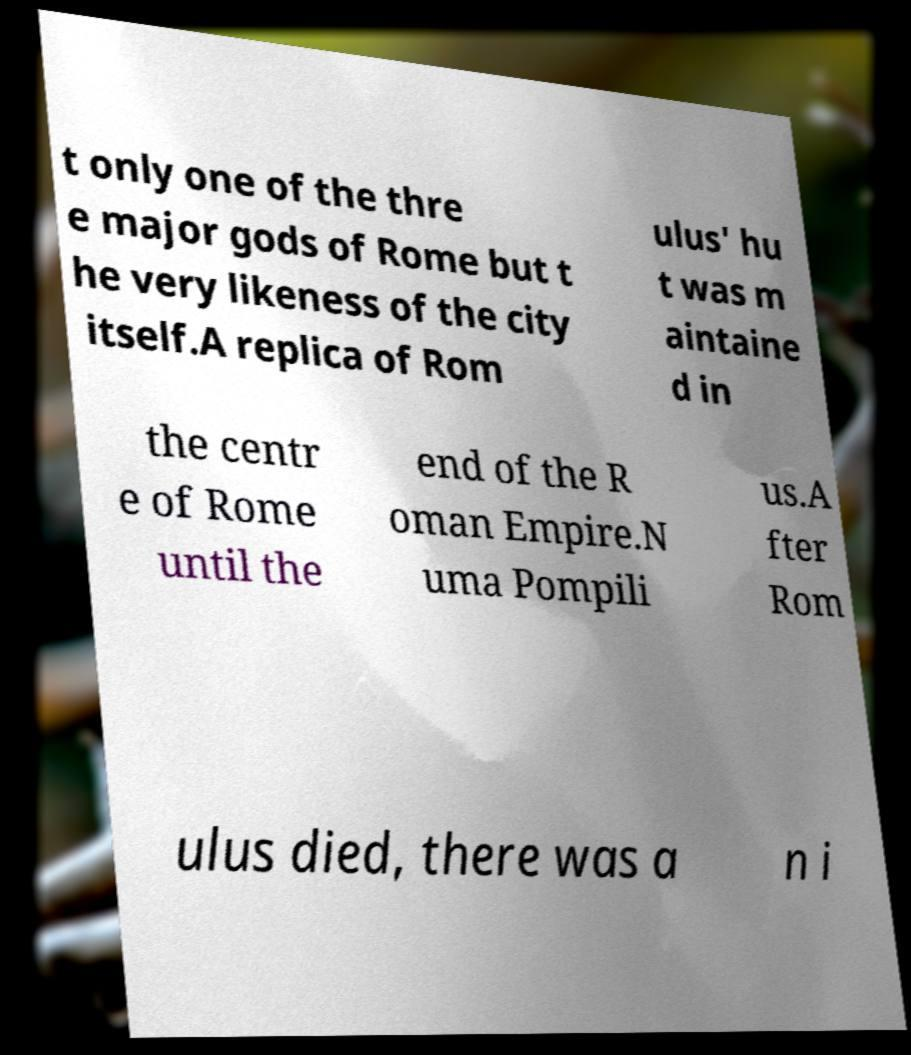I need the written content from this picture converted into text. Can you do that? t only one of the thre e major gods of Rome but t he very likeness of the city itself.A replica of Rom ulus' hu t was m aintaine d in the centr e of Rome until the end of the R oman Empire.N uma Pompili us.A fter Rom ulus died, there was a n i 